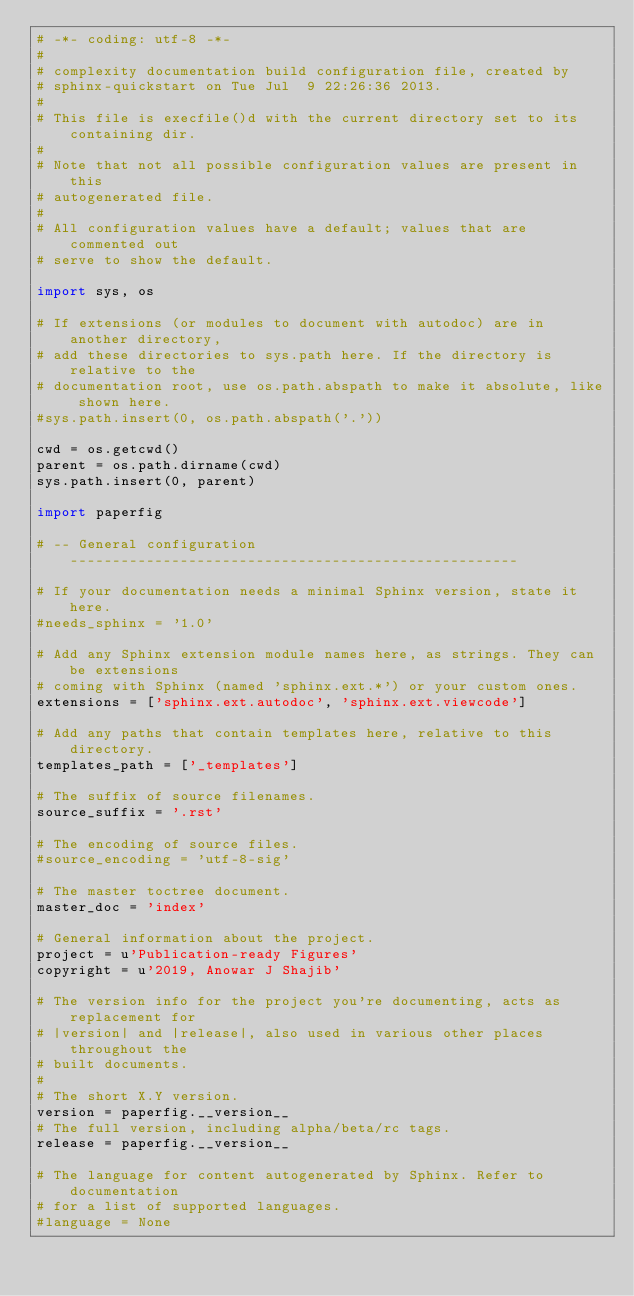Convert code to text. <code><loc_0><loc_0><loc_500><loc_500><_Python_># -*- coding: utf-8 -*-
#
# complexity documentation build configuration file, created by
# sphinx-quickstart on Tue Jul  9 22:26:36 2013.
#
# This file is execfile()d with the current directory set to its containing dir.
#
# Note that not all possible configuration values are present in this
# autogenerated file.
#
# All configuration values have a default; values that are commented out
# serve to show the default.

import sys, os

# If extensions (or modules to document with autodoc) are in another directory,
# add these directories to sys.path here. If the directory is relative to the
# documentation root, use os.path.abspath to make it absolute, like shown here.
#sys.path.insert(0, os.path.abspath('.'))

cwd = os.getcwd()
parent = os.path.dirname(cwd)
sys.path.insert(0, parent)

import paperfig

# -- General configuration -----------------------------------------------------

# If your documentation needs a minimal Sphinx version, state it here.
#needs_sphinx = '1.0'

# Add any Sphinx extension module names here, as strings. They can be extensions
# coming with Sphinx (named 'sphinx.ext.*') or your custom ones.
extensions = ['sphinx.ext.autodoc', 'sphinx.ext.viewcode']

# Add any paths that contain templates here, relative to this directory.
templates_path = ['_templates']

# The suffix of source filenames.
source_suffix = '.rst'

# The encoding of source files.
#source_encoding = 'utf-8-sig'

# The master toctree document.
master_doc = 'index'

# General information about the project.
project = u'Publication-ready Figures'
copyright = u'2019, Anowar J Shajib'

# The version info for the project you're documenting, acts as replacement for
# |version| and |release|, also used in various other places throughout the
# built documents.
#
# The short X.Y version.
version = paperfig.__version__
# The full version, including alpha/beta/rc tags.
release = paperfig.__version__

# The language for content autogenerated by Sphinx. Refer to documentation
# for a list of supported languages.
#language = None
</code> 